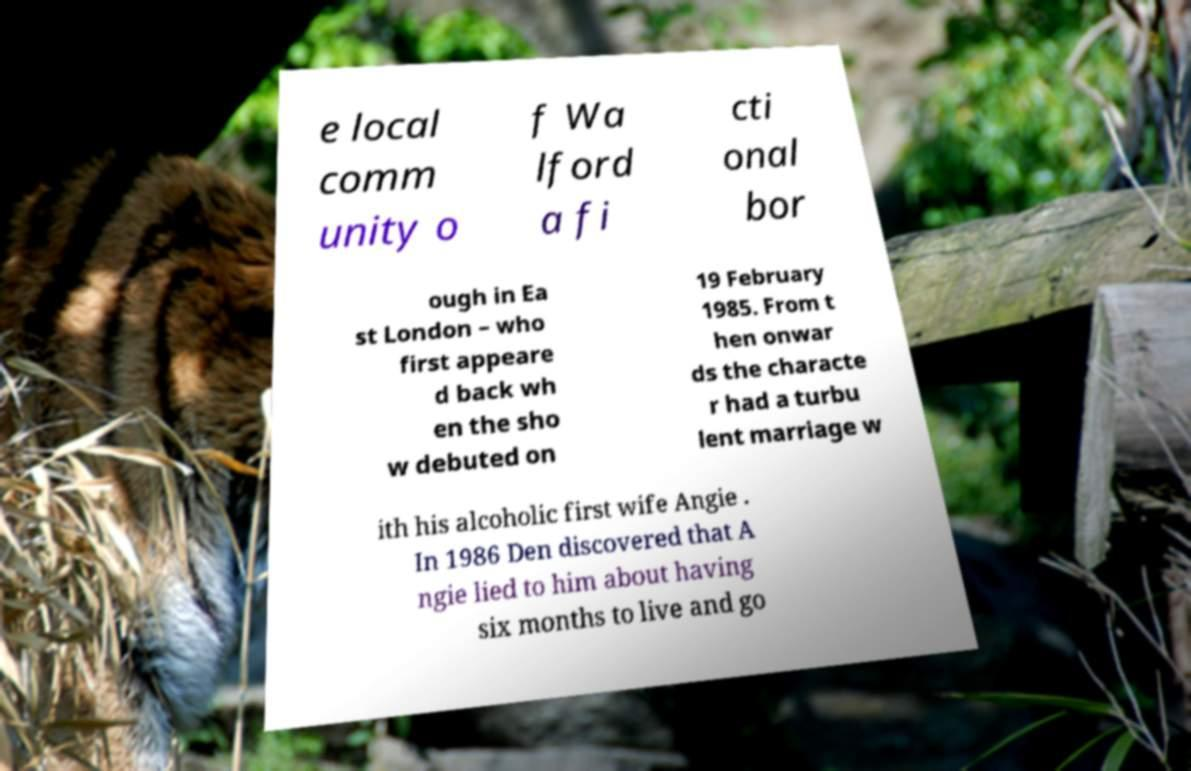Please identify and transcribe the text found in this image. e local comm unity o f Wa lford a fi cti onal bor ough in Ea st London – who first appeare d back wh en the sho w debuted on 19 February 1985. From t hen onwar ds the characte r had a turbu lent marriage w ith his alcoholic first wife Angie . In 1986 Den discovered that A ngie lied to him about having six months to live and go 